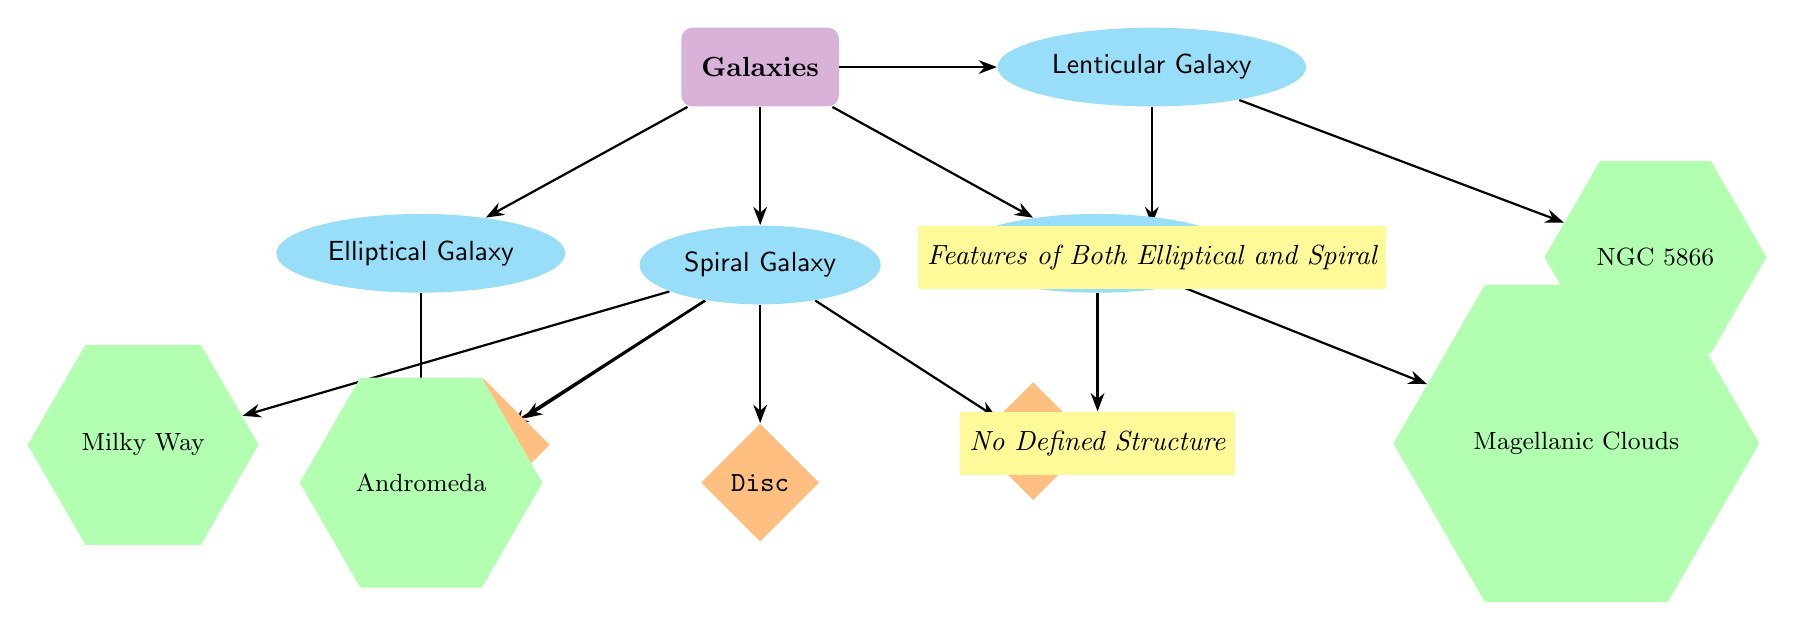What is the top category in the diagram? The top category is "Galaxies," which is the main node from which all other types of galaxies branch out.
Answer: Galaxies How many types of galaxies are illustrated in the diagram? There are four types of galaxies listed: Elliptical, Spiral, Irregular, and Lenticular, connected directly to the Galaxies node.
Answer: Four What structure is associated with Spiral Galaxies? The structures associated with Spiral Galaxies include Bulge, Disc, and Arms, all emanating from the Spiral Galaxy node.
Answer: Bulge, Disc, Arms Which example is listed under Spiral Galaxies? The two examples provided under Spiral Galaxies are Milky Way and Andromeda, as they are connected to the relevant structures.
Answer: Milky Way, Andromeda What is the classification range for Elliptical Galaxies? Elliptical Galaxies are classified within the range of E0 to E7 as indicated in the description node connected to the Elliptical Galaxy type.
Answer: E0 - E7 What defines Irregular Galaxies according to the diagram? Irregular Galaxies are defined by having "No Defined Structure," which is indicated in the description node connected to the Irregular Galaxy type.
Answer: No Defined Structure Which galaxy type shows mixed features? The Lenticular Galaxy type shows mixed features of both Elliptical and Spiral galaxies, as stated in the description node connected to it.
Answer: Features of Both Elliptical and Spiral Which example is associated with Irregular Galaxies? The example associated with Irregular Galaxies is the Magellanic Clouds, directly connected to the Irregular Galaxy node.
Answer: Magellanic Clouds How does the overwhelming structure of Spiral Galaxies differ from that of Elliptical Galaxies? Spiral Galaxies consist of Bulge, Disc, and Arms as their distinct structures, whereas Elliptical Galaxies are categorized simply by a range (E0 - E7) without specific structural components.
Answer: Bulge, Disc, Arms vs. E0 - E7 